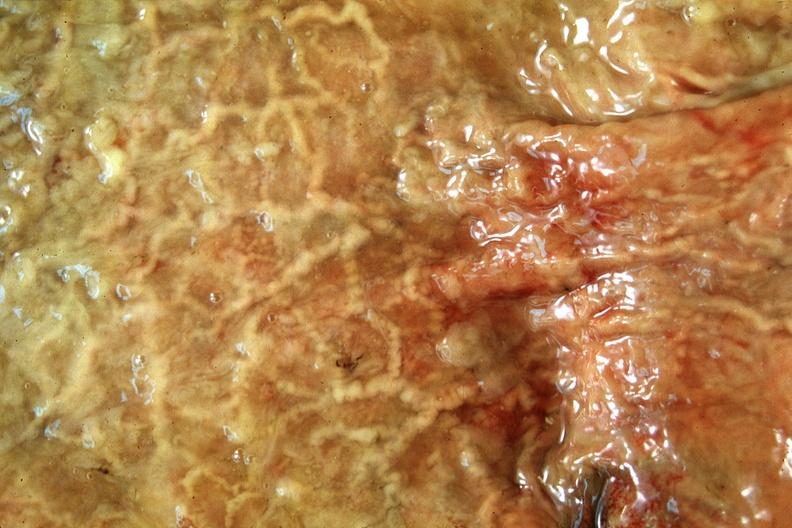does this image show normal stomach?
Answer the question using a single word or phrase. Yes 